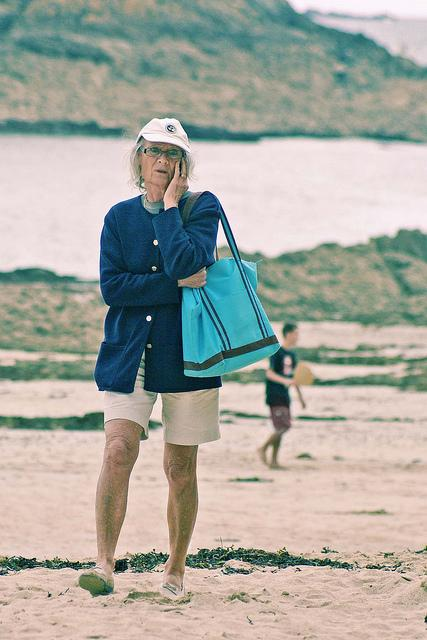What is the old woman doing?

Choices:
A) itching
B) using phone
C) laughing
D) massaging using phone 